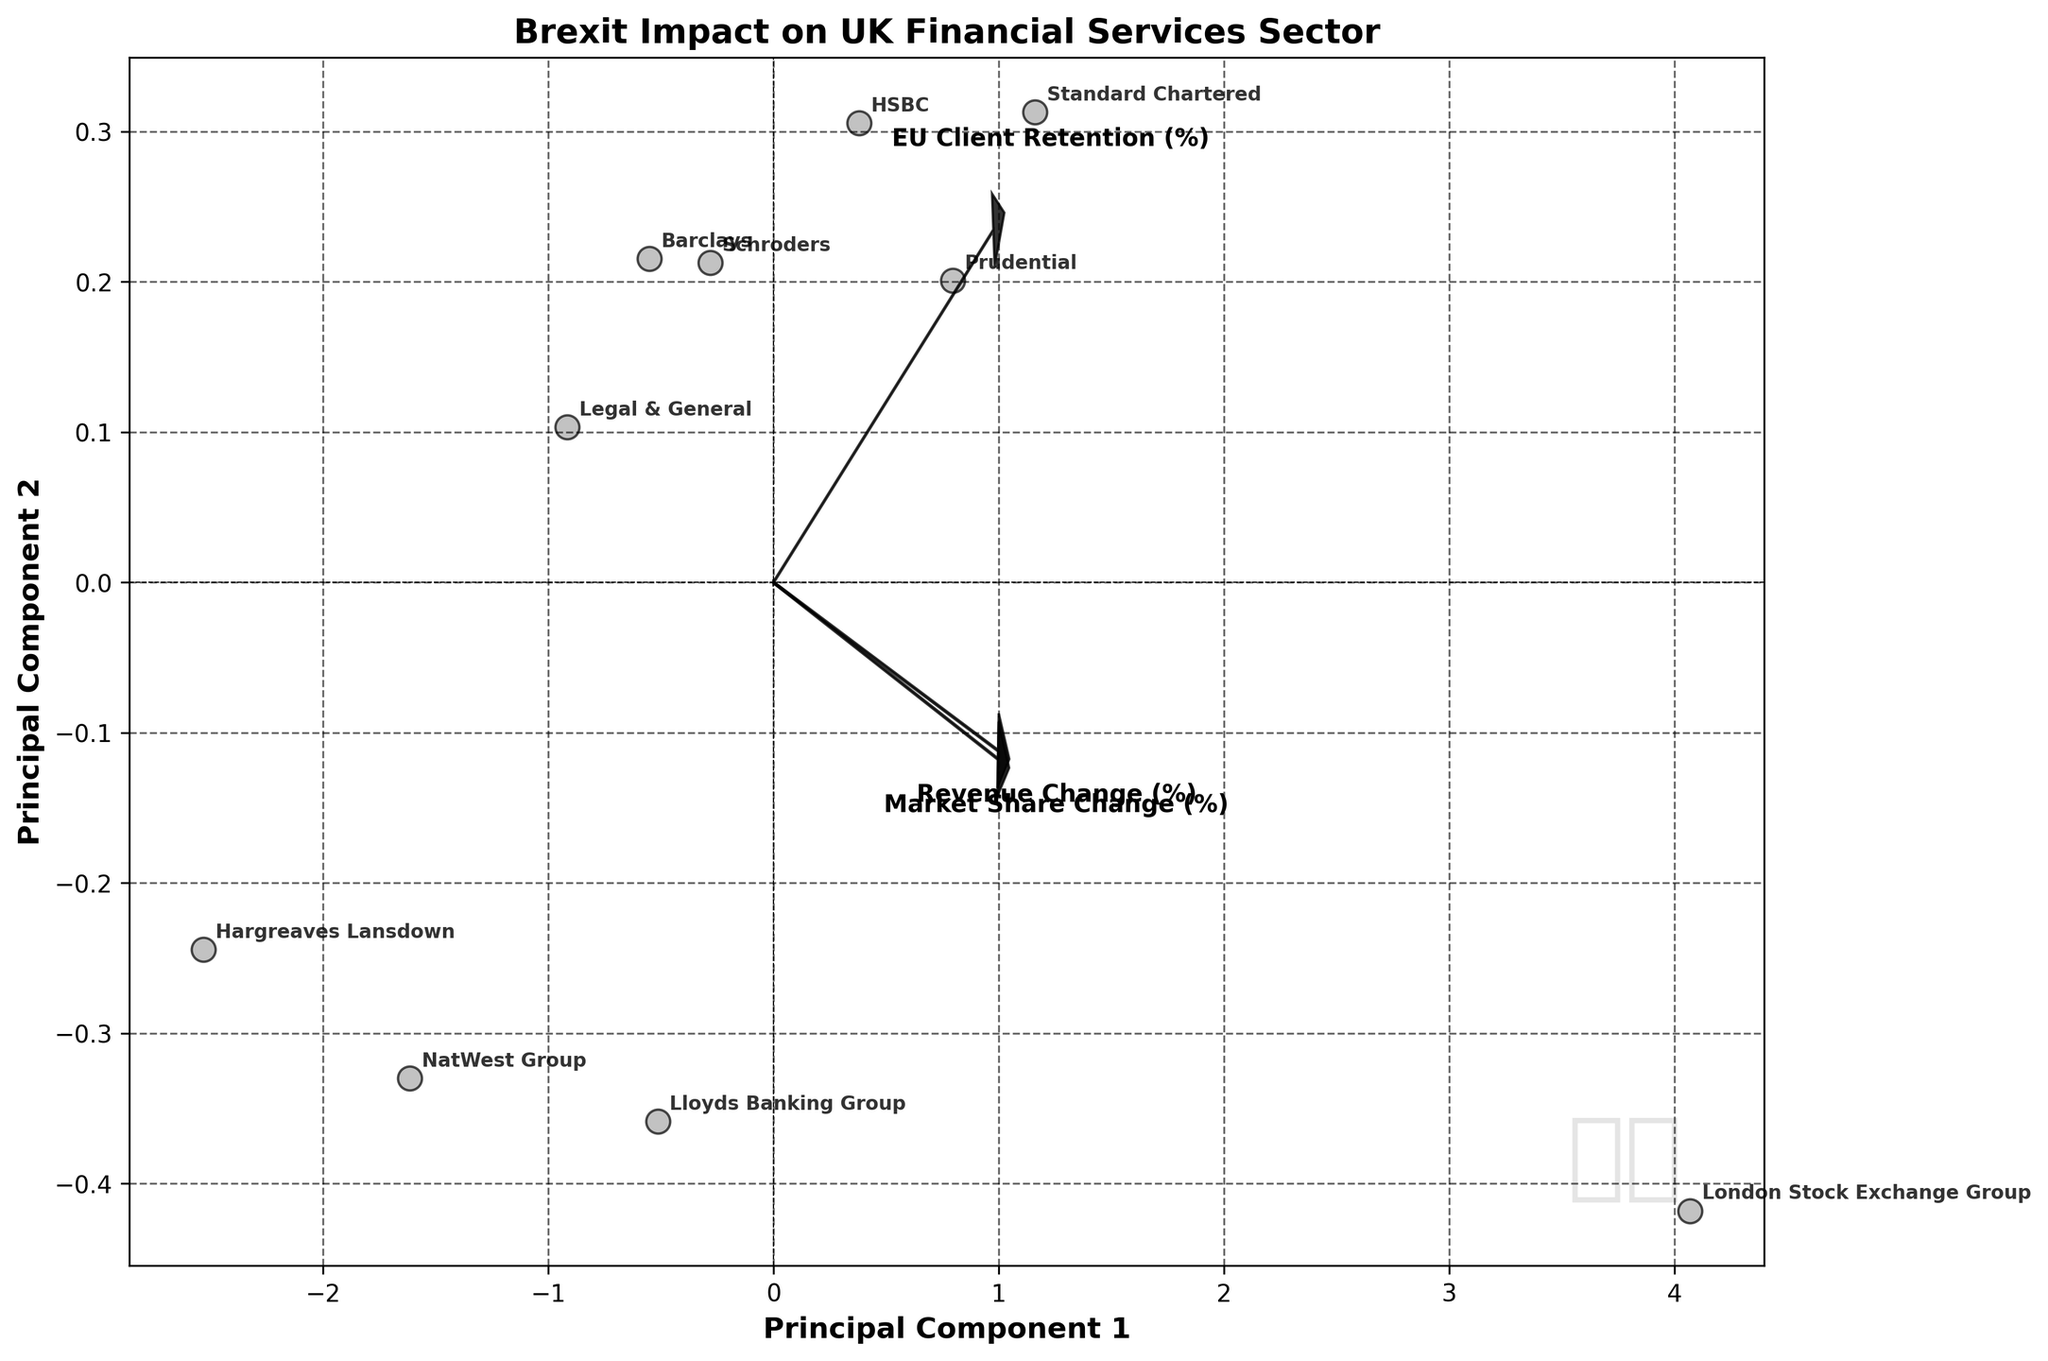how many institutions are plotted in the figure? Count all the unique institution labels in the scatter plot. There are 10 points, so there are 10 institutions plotted.
Answer: 10 How is the "Revenue Change (%)" feature represented in the biplot? Look for an arrow with a label indicating "Revenue Change (%)". The length and direction indicate the contribution of this feature to the principal components.
Answer: By an arrow Which institution has the highest "EU Client Retention (%)"? Check the biplot for the data point labels. The institution furthest in the direction of the "EU Client Retention (%)" arrow likely has the highest retention. "London Stock Exchange Group" appears furthest along that vector.
Answer: London Stock Exchange Group Which principal component mostly influences "Market Share Change (%)"? Identify the arrow labeled "Market Share Change (%)". Then, see which axis (Principal Component 1 or 2) it aligns more closely with. The arrow largely points along the Principal Component 1 axis.
Answer: Principal Component 1 What is the general trend of the points based on "Revenue Change (%)" and "Market Share Change (%)"? Observe the direction of the arrows for both features and the clustering of points. Most financial institutions show negative directions, indicating a general decrease in both revenue and market share.
Answer: Decreasing Which institutions have experienced both significant revenue and market share loss? Look for points that are farthest in the negative direction along the vectors of both "Revenue Change (%)" and "Market Share Change (%)". "Hargreaves Lansdown" is notably in this direction.
Answer: Hargreaves Lansdown Which feature shows the most variance based on the plot? Compare the lengths of the arrows representing the features. The longest arrow indicates the feature with the most variance. "EU Client Retention (%)" shows the most variance because its arrow is the longest.
Answer: EU Client Retention (%) Between NatWest Group and HSBC, which has lower EU client retention? Find both institutions on the plot and observe their positions in relation to the "EU Client Retention (%)" arrow. "NatWest Group" is positioned lower along this dimension compared to "HSBC".
Answer: NatWest Group 